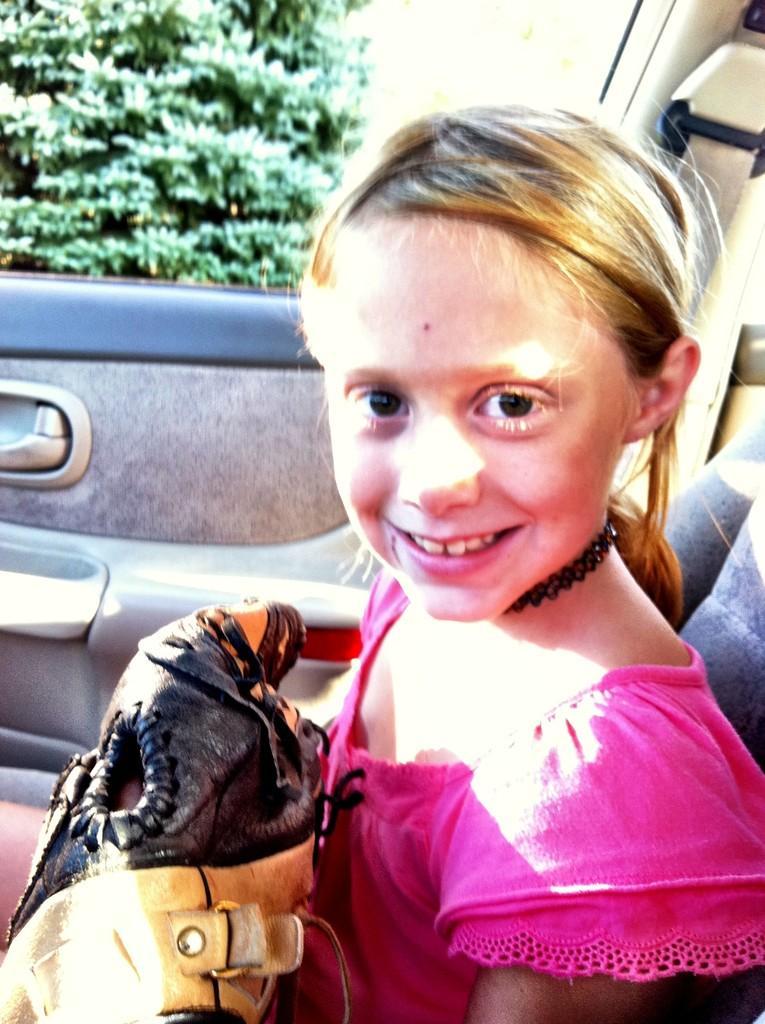In one or two sentences, can you explain what this image depicts? This image clicked in a car where it consists of a girl, who is in pink color dress. She is carrying a bag with her. There are trees on the top left corner. she is smiling. You can also see a seat belt on the top right corner. 